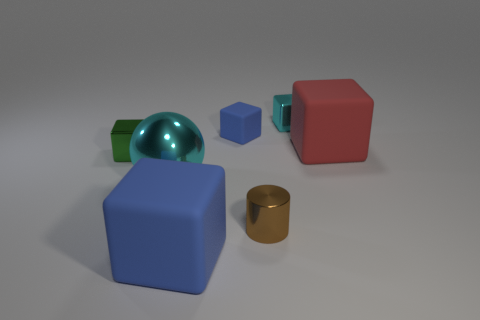Is there any other thing that has the same color as the large metallic ball?
Give a very brief answer. Yes. Are there more red cubes than things?
Your response must be concise. No. Do the big cyan ball and the large red thing have the same material?
Your answer should be very brief. No. How many small blue blocks are the same material as the red cube?
Offer a terse response. 1. There is a red rubber block; is its size the same as the cyan metallic object that is in front of the cyan metallic cube?
Your answer should be very brief. Yes. What color is the tiny thing that is both right of the small matte object and in front of the tiny matte block?
Your response must be concise. Brown. There is a large matte block that is behind the brown metal cylinder; is there a blue object in front of it?
Keep it short and to the point. Yes. Are there the same number of cylinders behind the small green metal thing and large gray objects?
Keep it short and to the point. Yes. There is a cyan object behind the matte thing that is to the right of the cyan shiny block; what number of red rubber things are to the right of it?
Give a very brief answer. 1. Are there any yellow spheres of the same size as the green thing?
Give a very brief answer. No. 